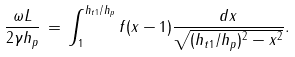Convert formula to latex. <formula><loc_0><loc_0><loc_500><loc_500>\frac { \omega L } { 2 \gamma h _ { p } } \, = \, \int _ { 1 } ^ { h _ { t 1 } / h _ { p } } f ( x - 1 ) \frac { d x } { \sqrt { ( h _ { t 1 } / h _ { p } ) ^ { 2 } - x ^ { 2 } } } .</formula> 